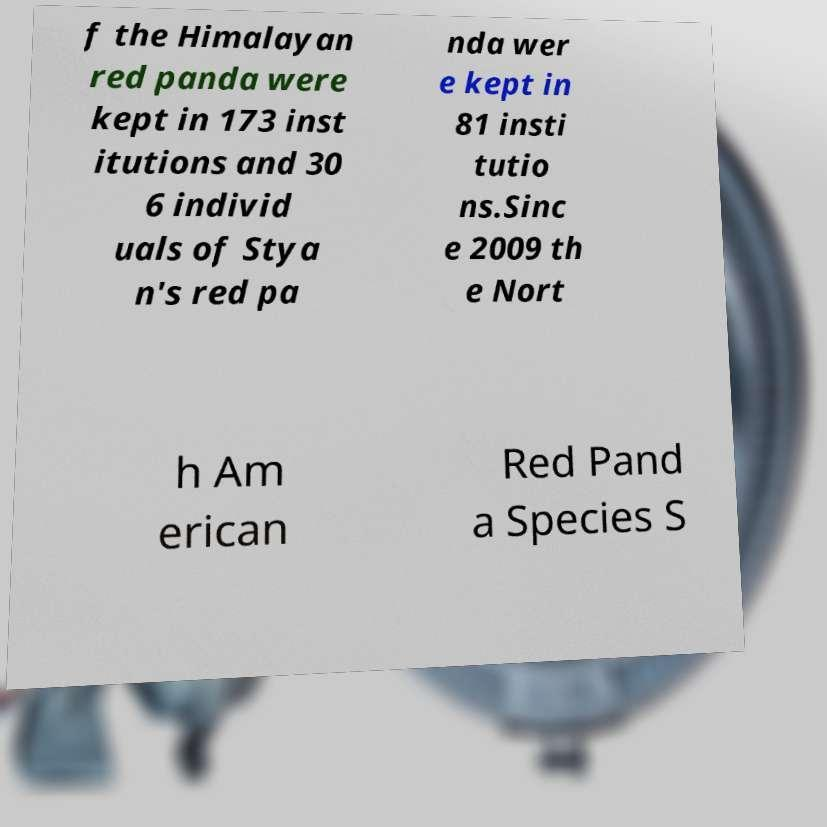I need the written content from this picture converted into text. Can you do that? f the Himalayan red panda were kept in 173 inst itutions and 30 6 individ uals of Stya n's red pa nda wer e kept in 81 insti tutio ns.Sinc e 2009 th e Nort h Am erican Red Pand a Species S 